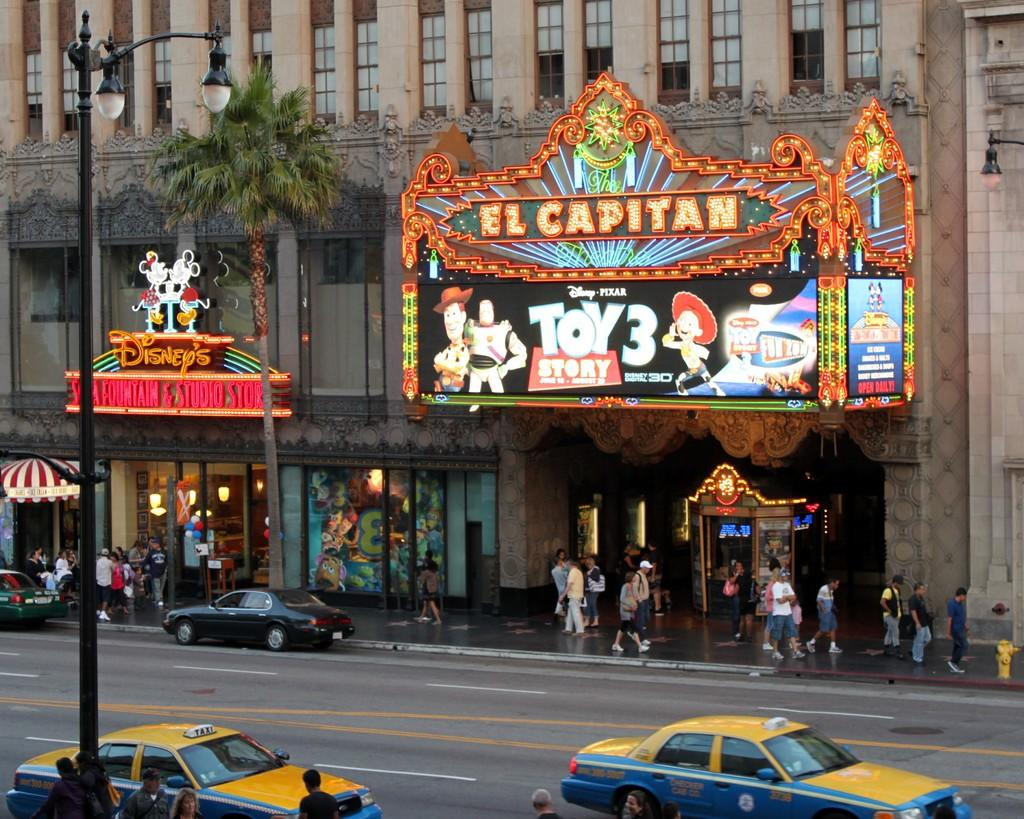Provide a one-sentence caption for the provided image. The outside of a theater with the words El Capitan written on it showing a banner for the movie Toy Story 3. 